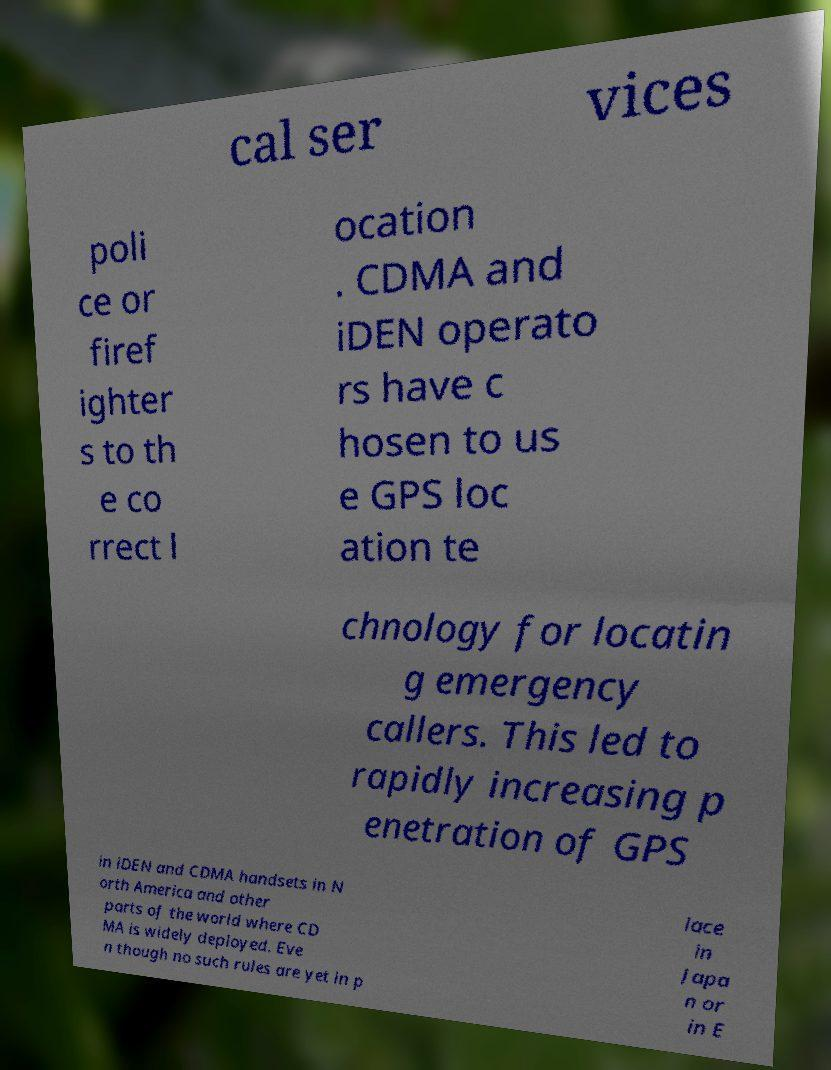Could you extract and type out the text from this image? cal ser vices poli ce or firef ighter s to th e co rrect l ocation . CDMA and iDEN operato rs have c hosen to us e GPS loc ation te chnology for locatin g emergency callers. This led to rapidly increasing p enetration of GPS in iDEN and CDMA handsets in N orth America and other parts of the world where CD MA is widely deployed. Eve n though no such rules are yet in p lace in Japa n or in E 